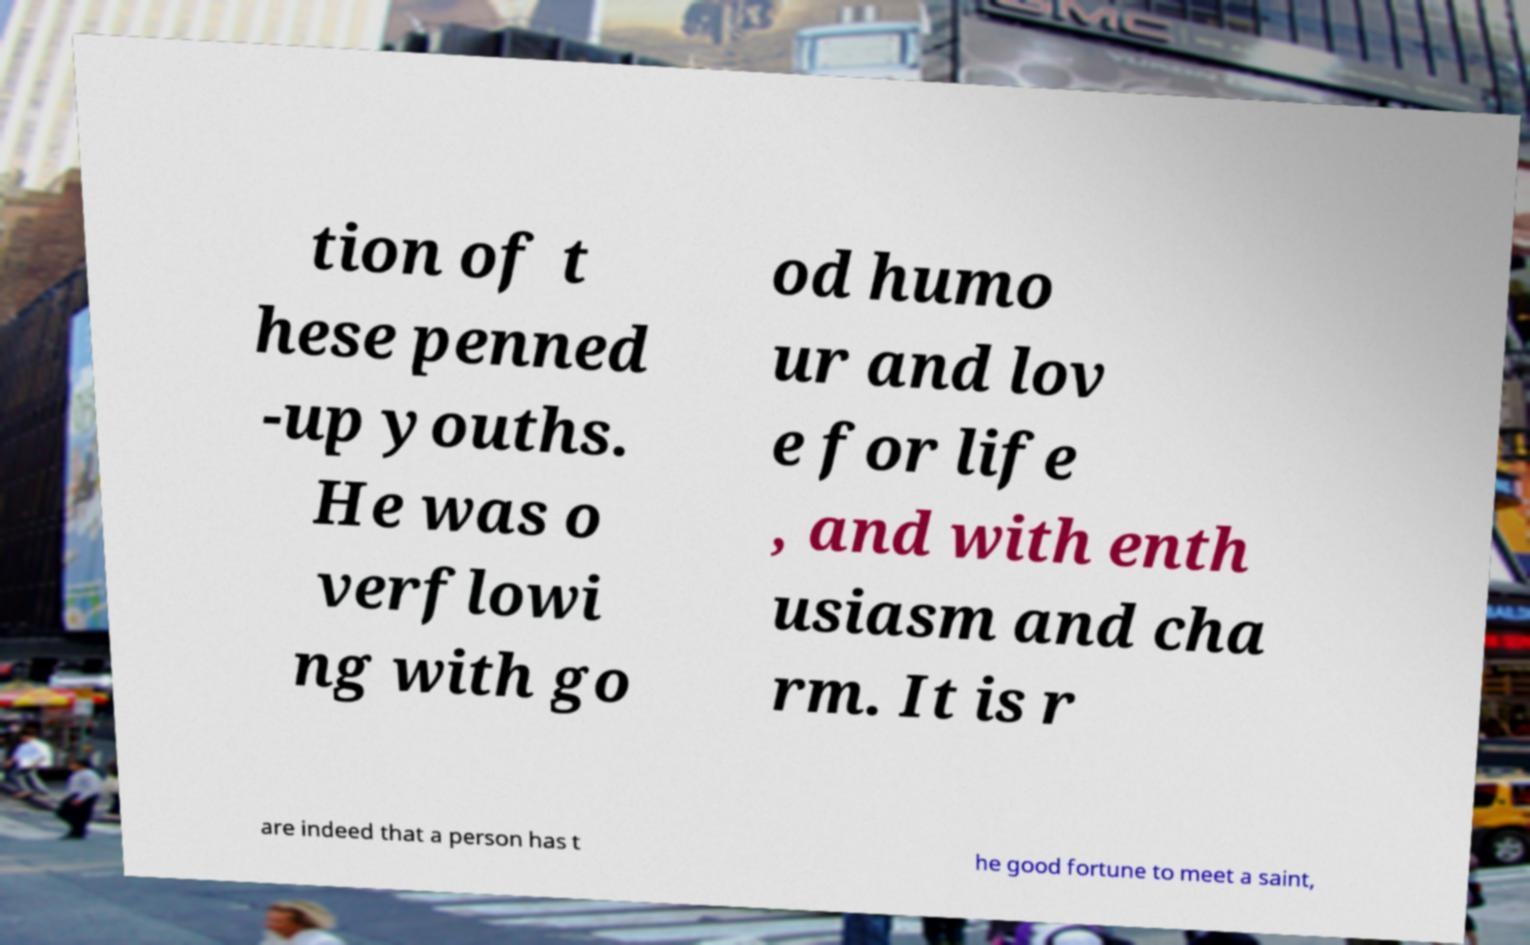Please read and relay the text visible in this image. What does it say? tion of t hese penned -up youths. He was o verflowi ng with go od humo ur and lov e for life , and with enth usiasm and cha rm. It is r are indeed that a person has t he good fortune to meet a saint, 